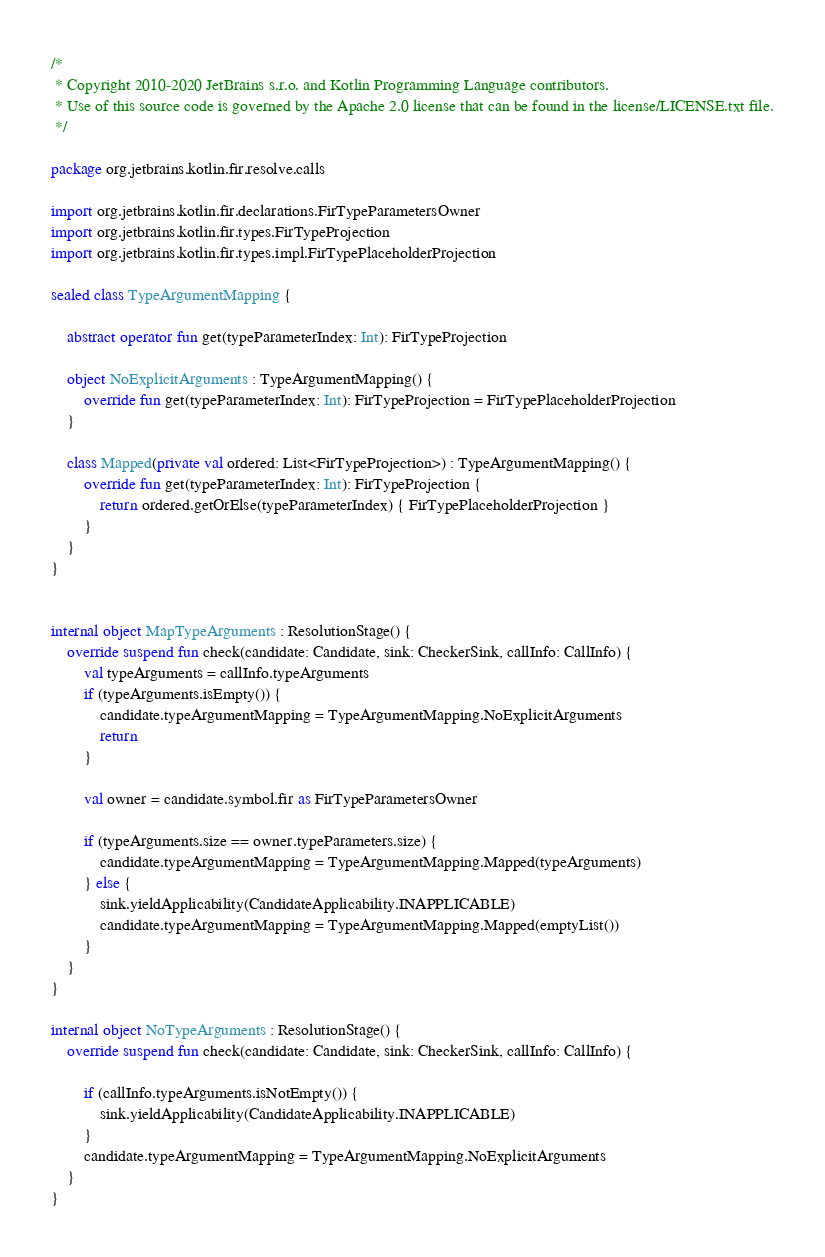Convert code to text. <code><loc_0><loc_0><loc_500><loc_500><_Kotlin_>/*
 * Copyright 2010-2020 JetBrains s.r.o. and Kotlin Programming Language contributors.
 * Use of this source code is governed by the Apache 2.0 license that can be found in the license/LICENSE.txt file.
 */

package org.jetbrains.kotlin.fir.resolve.calls

import org.jetbrains.kotlin.fir.declarations.FirTypeParametersOwner
import org.jetbrains.kotlin.fir.types.FirTypeProjection
import org.jetbrains.kotlin.fir.types.impl.FirTypePlaceholderProjection

sealed class TypeArgumentMapping {

    abstract operator fun get(typeParameterIndex: Int): FirTypeProjection

    object NoExplicitArguments : TypeArgumentMapping() {
        override fun get(typeParameterIndex: Int): FirTypeProjection = FirTypePlaceholderProjection
    }

    class Mapped(private val ordered: List<FirTypeProjection>) : TypeArgumentMapping() {
        override fun get(typeParameterIndex: Int): FirTypeProjection {
            return ordered.getOrElse(typeParameterIndex) { FirTypePlaceholderProjection }
        }
    }
}


internal object MapTypeArguments : ResolutionStage() {
    override suspend fun check(candidate: Candidate, sink: CheckerSink, callInfo: CallInfo) {
        val typeArguments = callInfo.typeArguments
        if (typeArguments.isEmpty()) {
            candidate.typeArgumentMapping = TypeArgumentMapping.NoExplicitArguments
            return
        }

        val owner = candidate.symbol.fir as FirTypeParametersOwner

        if (typeArguments.size == owner.typeParameters.size) {
            candidate.typeArgumentMapping = TypeArgumentMapping.Mapped(typeArguments)
        } else {
            sink.yieldApplicability(CandidateApplicability.INAPPLICABLE)
            candidate.typeArgumentMapping = TypeArgumentMapping.Mapped(emptyList())
        }
    }
}

internal object NoTypeArguments : ResolutionStage() {
    override suspend fun check(candidate: Candidate, sink: CheckerSink, callInfo: CallInfo) {

        if (callInfo.typeArguments.isNotEmpty()) {
            sink.yieldApplicability(CandidateApplicability.INAPPLICABLE)
        }
        candidate.typeArgumentMapping = TypeArgumentMapping.NoExplicitArguments
    }
}</code> 